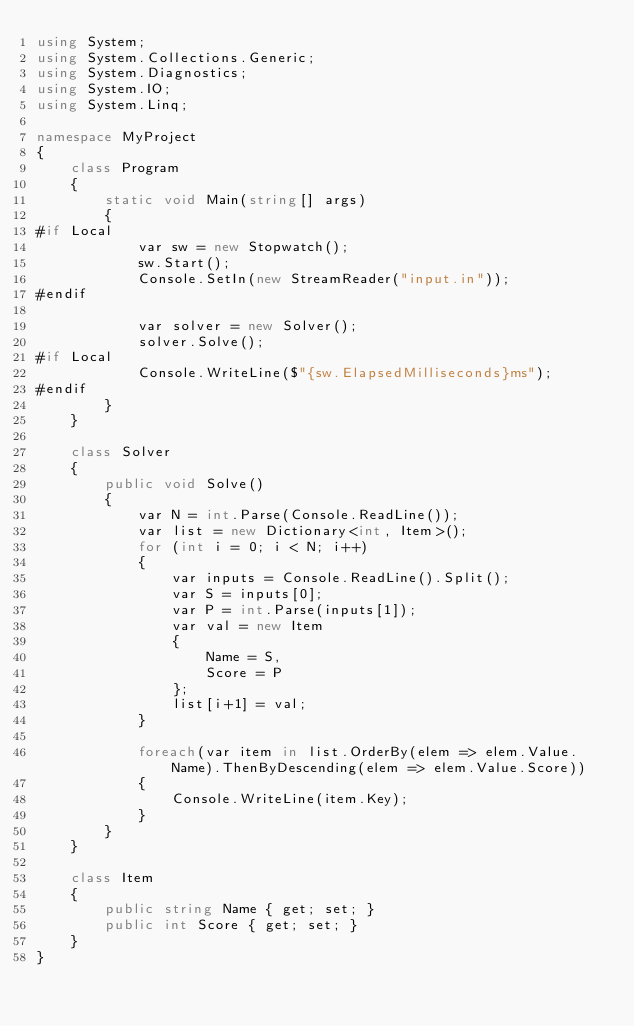<code> <loc_0><loc_0><loc_500><loc_500><_C#_>using System;
using System.Collections.Generic;
using System.Diagnostics;
using System.IO;
using System.Linq;

namespace MyProject
{
    class Program
    {
        static void Main(string[] args)
        {
#if Local
            var sw = new Stopwatch();
            sw.Start();
            Console.SetIn(new StreamReader("input.in"));
#endif

            var solver = new Solver();
            solver.Solve();
#if Local
            Console.WriteLine($"{sw.ElapsedMilliseconds}ms");
#endif
        }
    }

    class Solver
    {
        public void Solve()
        {
            var N = int.Parse(Console.ReadLine());
            var list = new Dictionary<int, Item>();
            for (int i = 0; i < N; i++)
            {
                var inputs = Console.ReadLine().Split();
                var S = inputs[0];
                var P = int.Parse(inputs[1]);
                var val = new Item
                {
                    Name = S,
                    Score = P
                };
                list[i+1] = val;
            }

            foreach(var item in list.OrderBy(elem => elem.Value.Name).ThenByDescending(elem => elem.Value.Score))
            {
                Console.WriteLine(item.Key);
            }
        }
    }

    class Item
    {
        public string Name { get; set; }
        public int Score { get; set; }
    }
}
</code> 